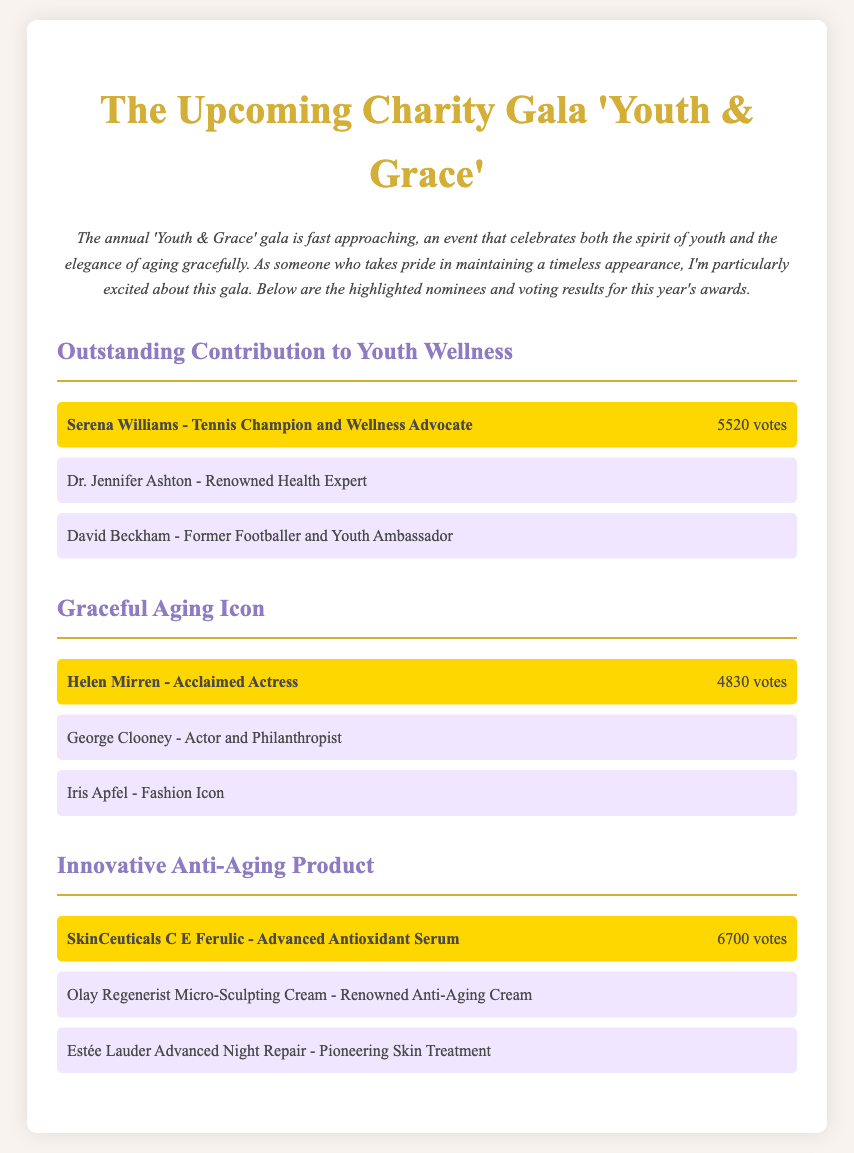What is the title of the gala? The title of the gala is mentioned at the beginning of the document.
Answer: Youth & Grace Who won the award for Graceful Aging Icon? The winner is highlighted within the section for this category.
Answer: Helen Mirren How many votes did SkinCeuticals C E Ferulic receive? The number of votes is indicated next to the winning nominee in the Innovative Anti-Aging Product category.
Answer: 6700 votes What category is David Beckham nominated for? The document lists the categories and nominees; David Beckham appears under a specific category.
Answer: Outstanding Contribution to Youth Wellness Which nominee received the highest number of votes? This can be determined by comparing the votes listed for each nominee in the document.
Answer: SkinCeuticals C E Ferulic What is the focus of the 'Youth & Grace' gala? The introduction provides insight into the purpose of the gala.
Answer: Celebrating youth and grace in aging Who is a nominee in the category of Innovative Anti-Aging Product? The document lists nominees for each category, with some being highlighted.
Answer: Olay Regenerist Micro-Sculpting Cream How many votes did Helen Mirren receive? The votes for each nominee are mentioned directly in the document.
Answer: 4830 votes What color is used for the winner's background? The document describes the styling for different elements, including the winner.
Answer: Gold 